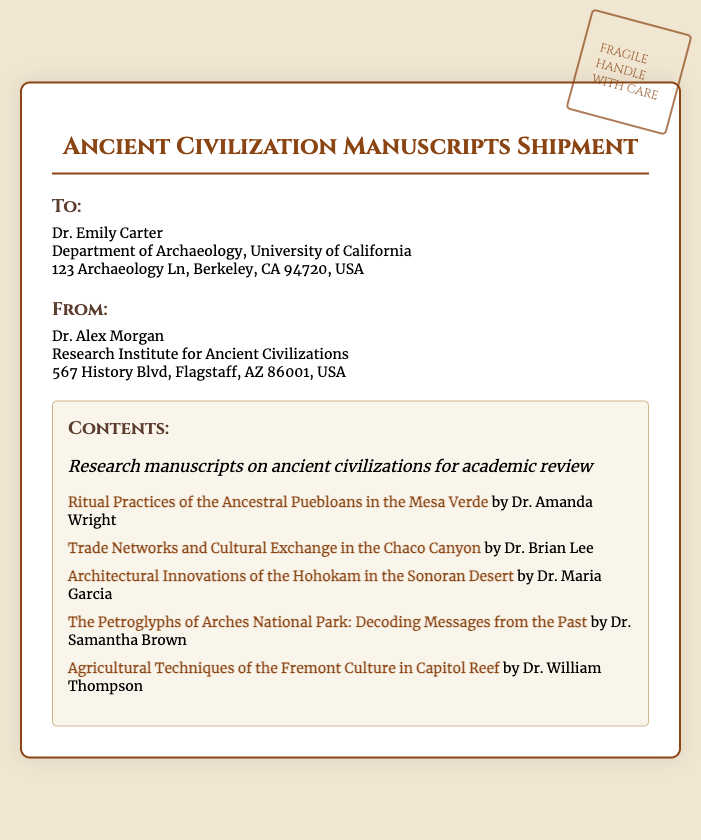What is the name of the recipient? The recipient's name is mentioned in the address section of the document, indicating who will receive the shipment.
Answer: Dr. Emily Carter Where is the sender located? The sender's address is provided in the document, specifying their location.
Answer: 567 History Blvd, Flagstaff, AZ 86001, USA How many manuscripts are listed in the contents? The number of manuscripts can be determined by counting the items in the list within the contents section.
Answer: 5 What is the title of the manuscript by Dr. Amanda Wright? The title is listed in the contents section next to the author's name.
Answer: Ritual Practices of the Ancestral Puebloans in the Mesa Verde Which university is Dr. Emily Carter affiliated with? The document states the institution associated with the recipient in the address section.
Answer: University of California What is the purpose of the shipment? The document clearly outlines the intent behind the shipment in the contents section.
Answer: Academic review What does the stamp on the shipping label indicate? The stamp contains instructions on how to handle the package, indicating special care.
Answer: Handle with care Which ancient civilization is associated with the research of Dr. Maria Garcia? The title provided in the document reveals the focus of Dr. Maria Garcia's research.
Answer: Hohokam 